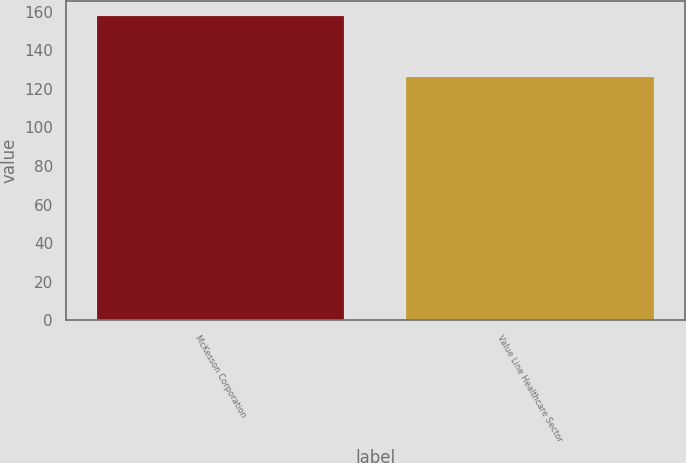<chart> <loc_0><loc_0><loc_500><loc_500><bar_chart><fcel>McKesson Corporation<fcel>Value Line Healthcare Sector<nl><fcel>157.65<fcel>126.05<nl></chart> 